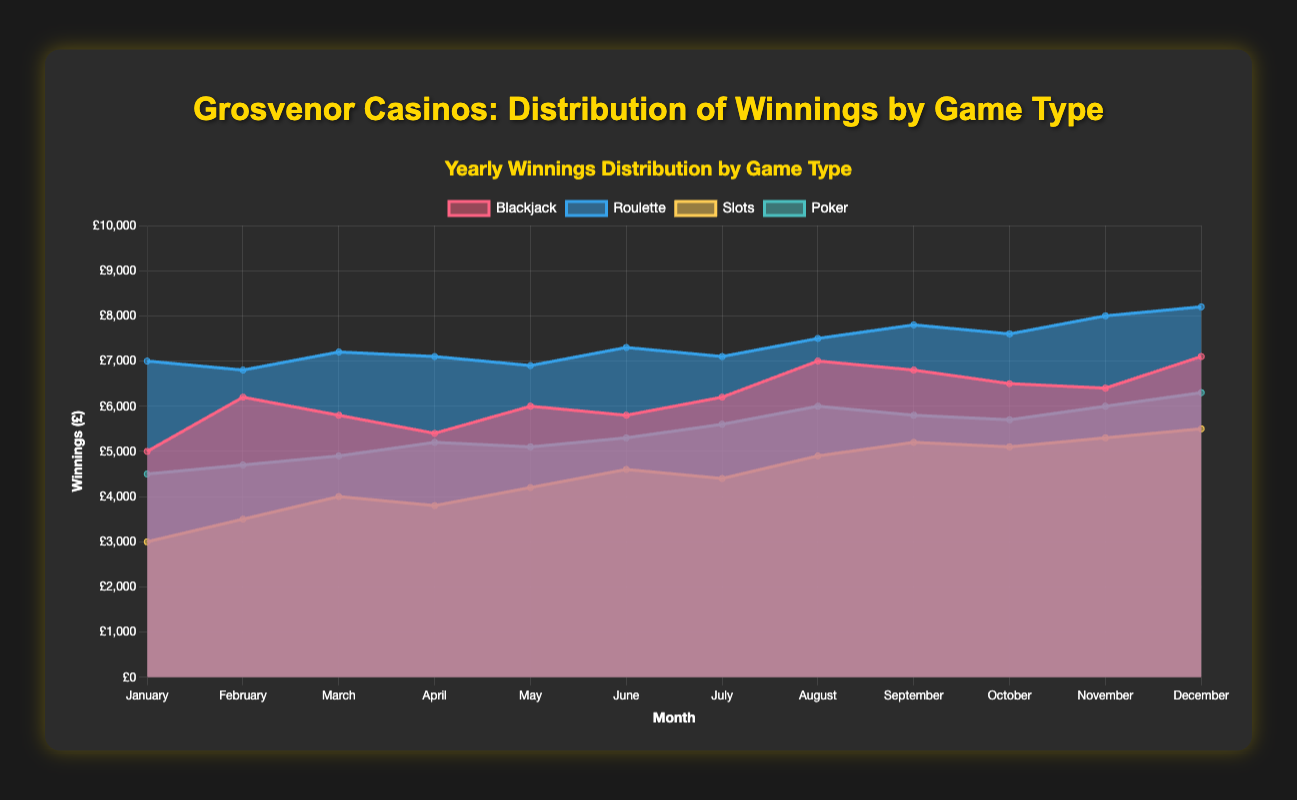What is the title of the chart? The title of the chart is displayed at the top in bold and highlighted text.
Answer: Grosvenor Casinos: Distribution of Winnings by Game Type Which game type has the highest winnings in December? In December, the highest point on the y-axis corresponds to the 'Roulette' dataset.
Answer: Roulette How do the Blackjack winnings trend over the year? By observing the line representing Blackjack, the winnings fluctuate but generally increase from January to December.
Answer: Increasing trend Which month had the lowest winnings for Slots? By looking at the lowest point of the yellow area representing Slots, the lowest winnings are in January.
Answer: January What was the total winnings for Poker in July and August combined? Add the values for Poker in July (5600) and August (6000).
Answer: 11600 During which month did Roulette winnings surpass 8000? Check the 'Roulette' data points; it surpasses 8000 in November and December.
Answer: November and December Compare the winnings of Blackjack and Poker in June. Which one had higher winnings? Check the values: Blackjack = 5800, Poker = 5300. Blackjack had higher winnings.
Answer: Blackjack Which game type shows the most variability over the year? By comparing the range between the highest and lowest values, 'Roulette' shows the most variability.
Answer: Roulette How do the winnings for slots compare from January to December? The winnings for Slots start at 3000 in January and increase to 5500 in December, showing an upward trend.
Answer: Upward trend Did any game have its peak earnings in April? By checking the peaks for each game in April, none of the datasets have their highest values in April.
Answer: No 